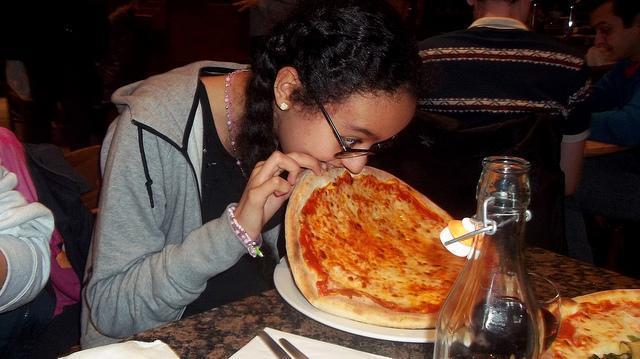How many people are there?
Give a very brief answer. 5. How many pizzas are in the photo?
Give a very brief answer. 2. 